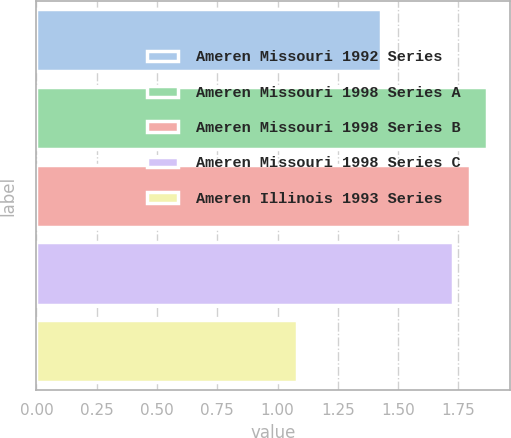Convert chart. <chart><loc_0><loc_0><loc_500><loc_500><bar_chart><fcel>Ameren Missouri 1992 Series<fcel>Ameren Missouri 1998 Series A<fcel>Ameren Missouri 1998 Series B<fcel>Ameren Missouri 1998 Series C<fcel>Ameren Illinois 1993 Series<nl><fcel>1.43<fcel>1.87<fcel>1.8<fcel>1.73<fcel>1.08<nl></chart> 